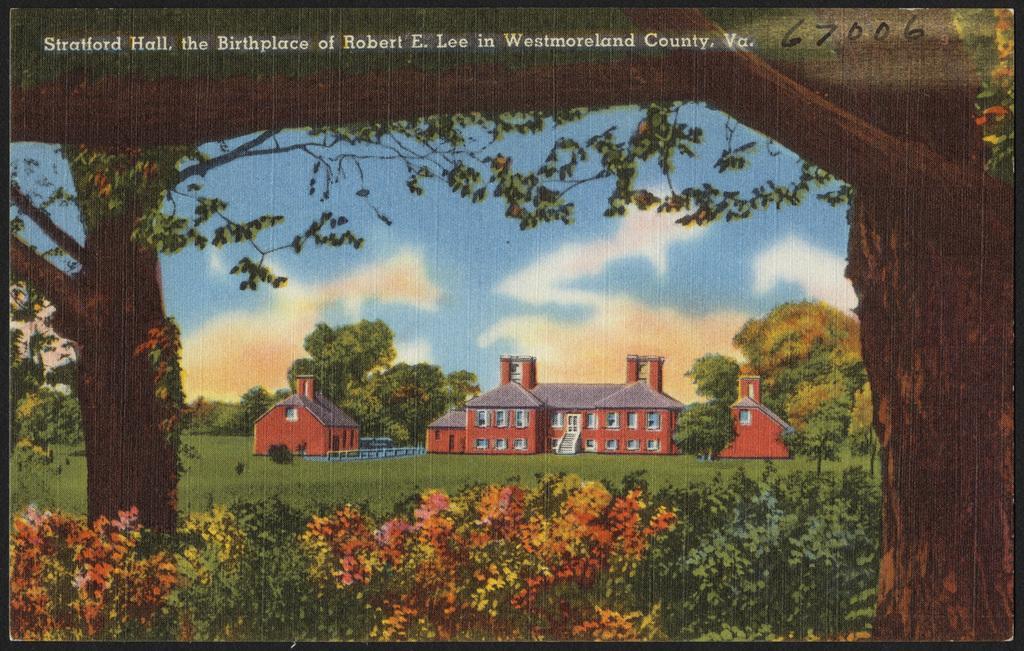Can you describe this image briefly? In this picture we can see a paper and in the paper there are houses and behind the houses there are trees and the sky. On the paper it is written something. 